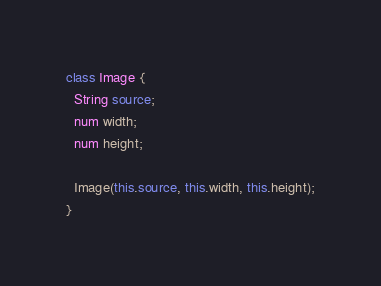Convert code to text. <code><loc_0><loc_0><loc_500><loc_500><_Dart_>class Image {
  String source;
  num width;
  num height;

  Image(this.source, this.width, this.height);
}
</code> 